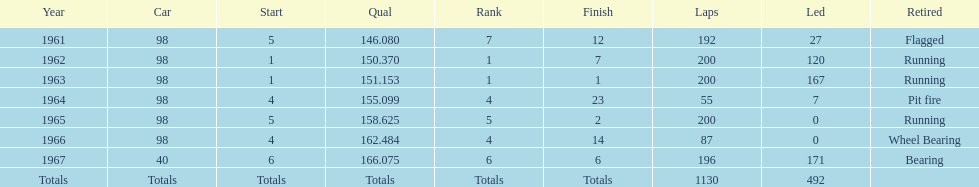Which vehicle accomplished the highest qual achievement? 40. 